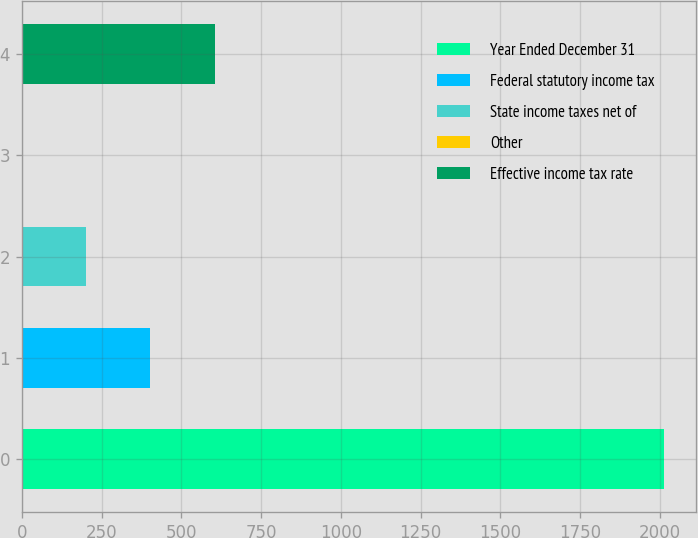<chart> <loc_0><loc_0><loc_500><loc_500><bar_chart><fcel>Year Ended December 31<fcel>Federal statutory income tax<fcel>State income taxes net of<fcel>Other<fcel>Effective income tax rate<nl><fcel>2013<fcel>402.68<fcel>201.39<fcel>0.1<fcel>603.97<nl></chart> 